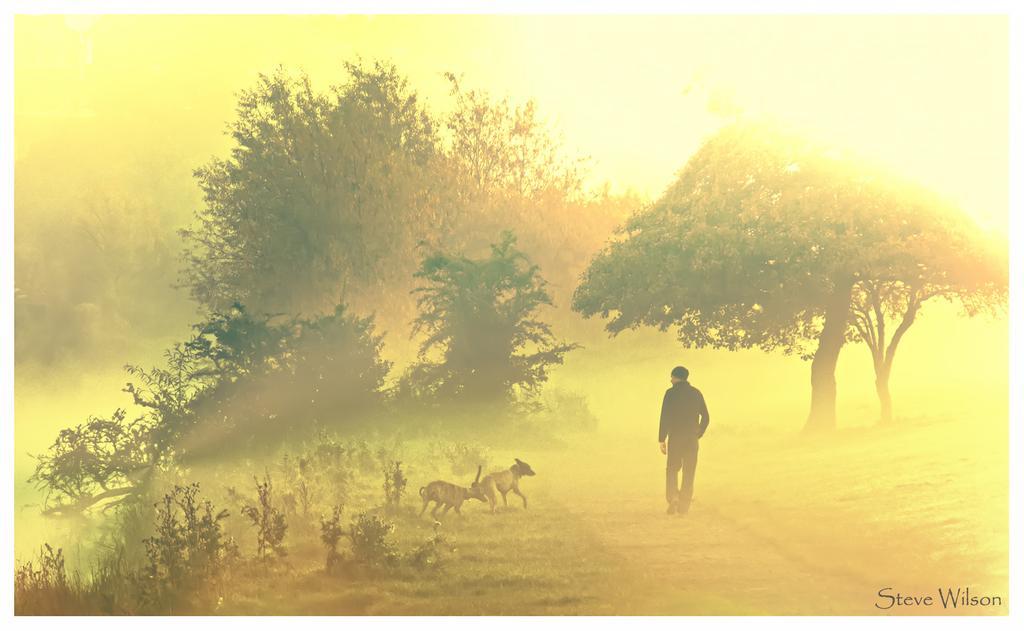Describe this image in one or two sentences. This is a painting and here we can see a person walking and there are some animals. In the background, there are trees. 